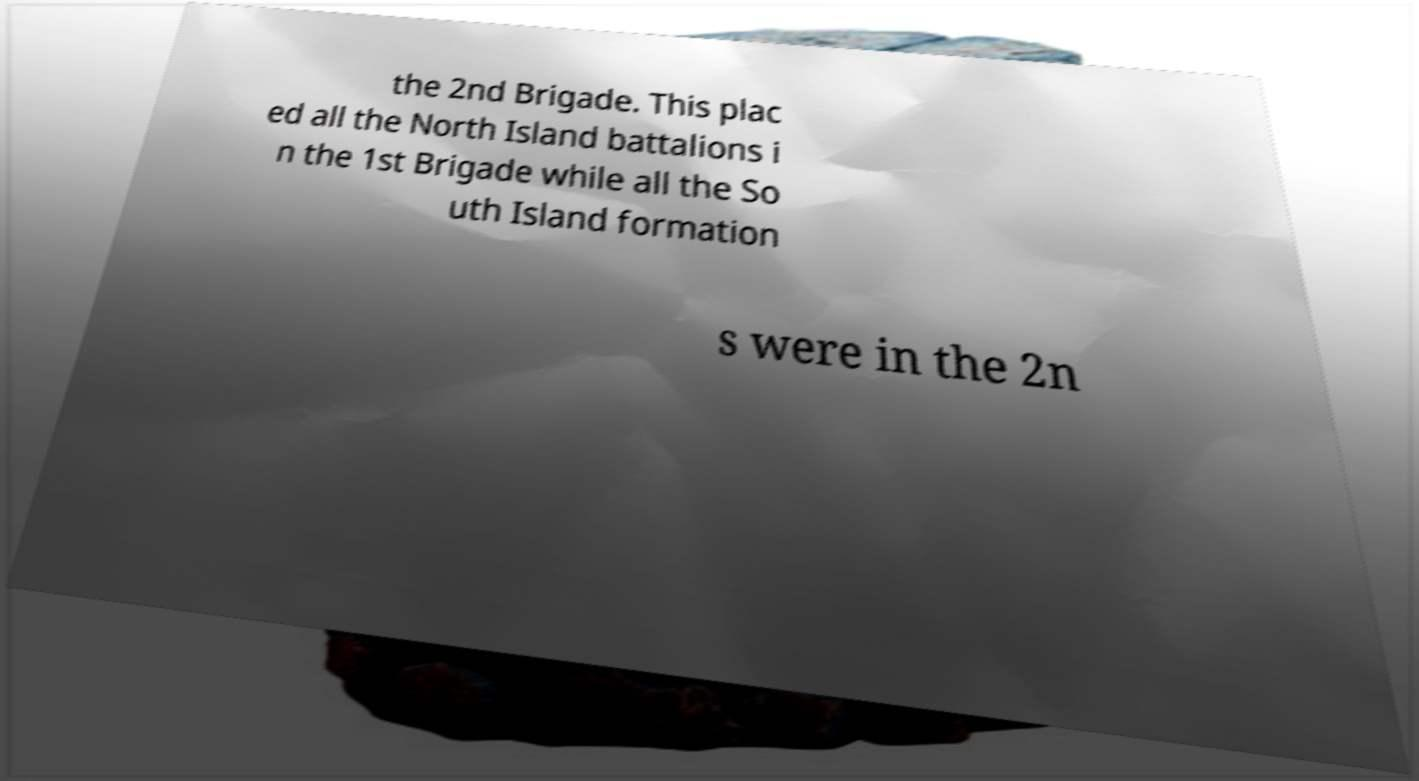I need the written content from this picture converted into text. Can you do that? the 2nd Brigade. This plac ed all the North Island battalions i n the 1st Brigade while all the So uth Island formation s were in the 2n 